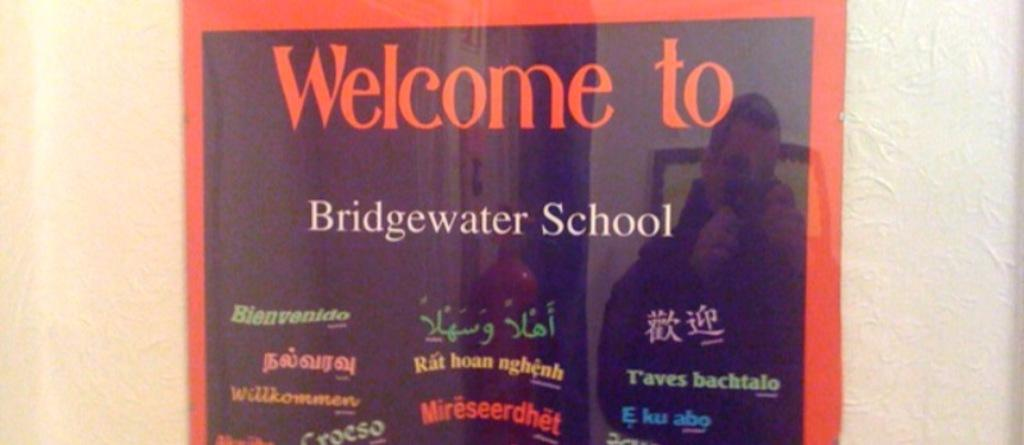Provide a one-sentence caption for the provided image. A poster that says "Welcome to Bridgewater School.". 